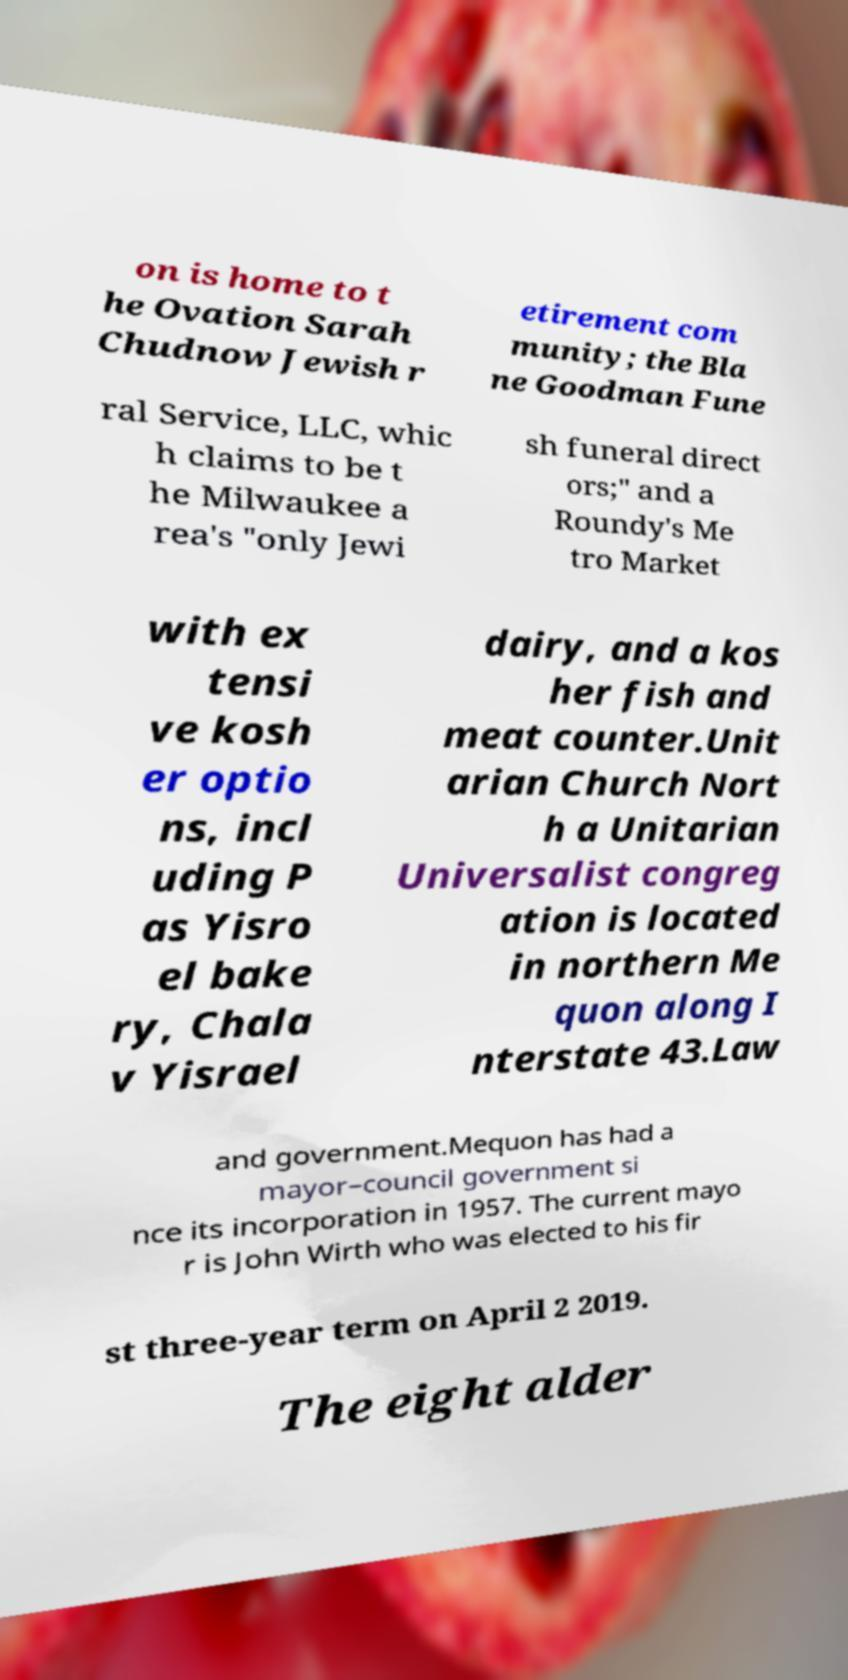Please read and relay the text visible in this image. What does it say? on is home to t he Ovation Sarah Chudnow Jewish r etirement com munity; the Bla ne Goodman Fune ral Service, LLC, whic h claims to be t he Milwaukee a rea's "only Jewi sh funeral direct ors;" and a Roundy's Me tro Market with ex tensi ve kosh er optio ns, incl uding P as Yisro el bake ry, Chala v Yisrael dairy, and a kos her fish and meat counter.Unit arian Church Nort h a Unitarian Universalist congreg ation is located in northern Me quon along I nterstate 43.Law and government.Mequon has had a mayor–council government si nce its incorporation in 1957. The current mayo r is John Wirth who was elected to his fir st three-year term on April 2 2019. The eight alder 